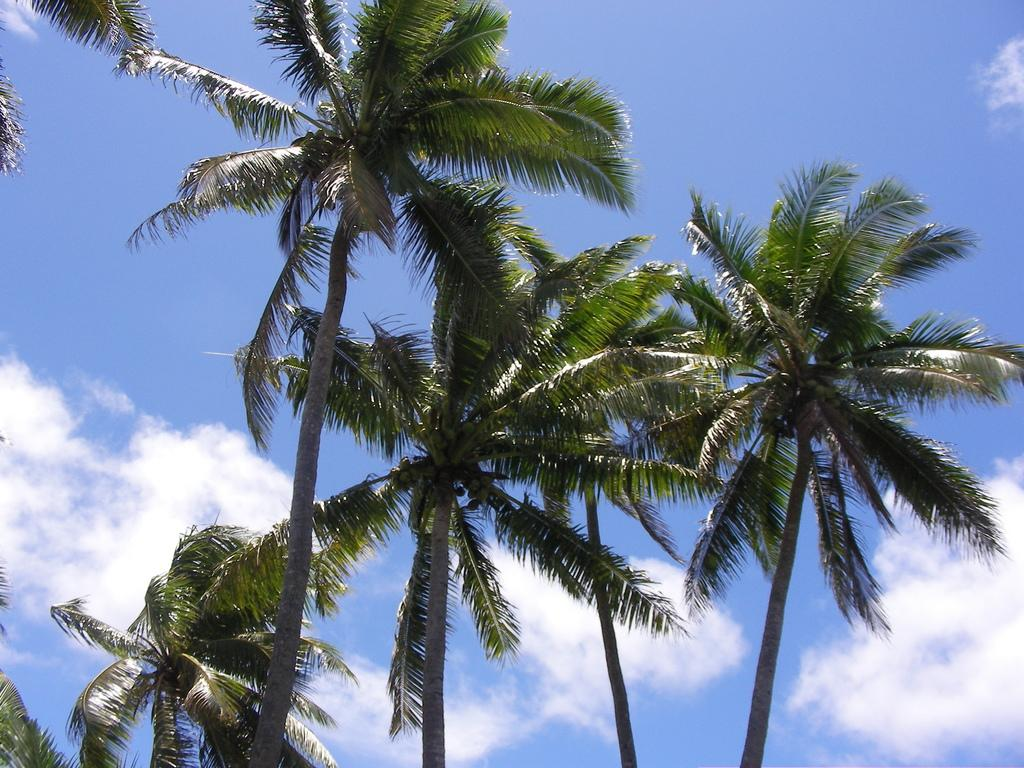What type of vegetation can be seen in the image? The image contains trees. What can be seen in the sky at the top of the image? There are clouds visible in the sky at the top of the image. What type of vein is visible in the image? There is no vein visible in the image; it features trees and clouds. 